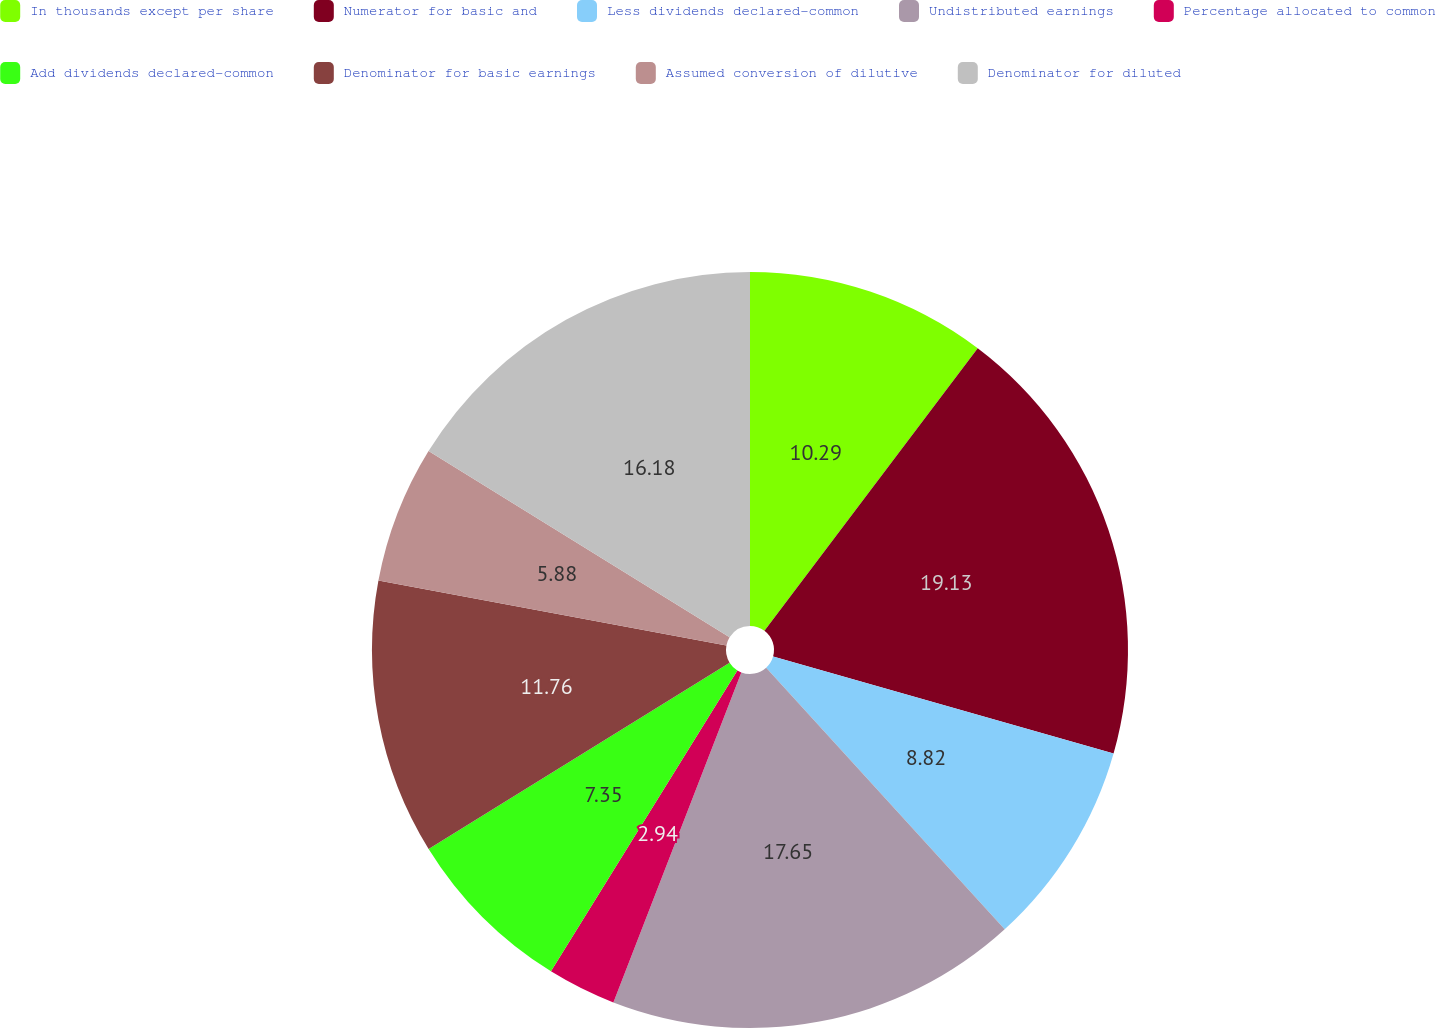Convert chart to OTSL. <chart><loc_0><loc_0><loc_500><loc_500><pie_chart><fcel>In thousands except per share<fcel>Numerator for basic and<fcel>Less dividends declared-common<fcel>Undistributed earnings<fcel>Percentage allocated to common<fcel>Add dividends declared-common<fcel>Denominator for basic earnings<fcel>Assumed conversion of dilutive<fcel>Denominator for diluted<nl><fcel>10.29%<fcel>19.12%<fcel>8.82%<fcel>17.65%<fcel>2.94%<fcel>7.35%<fcel>11.76%<fcel>5.88%<fcel>16.18%<nl></chart> 